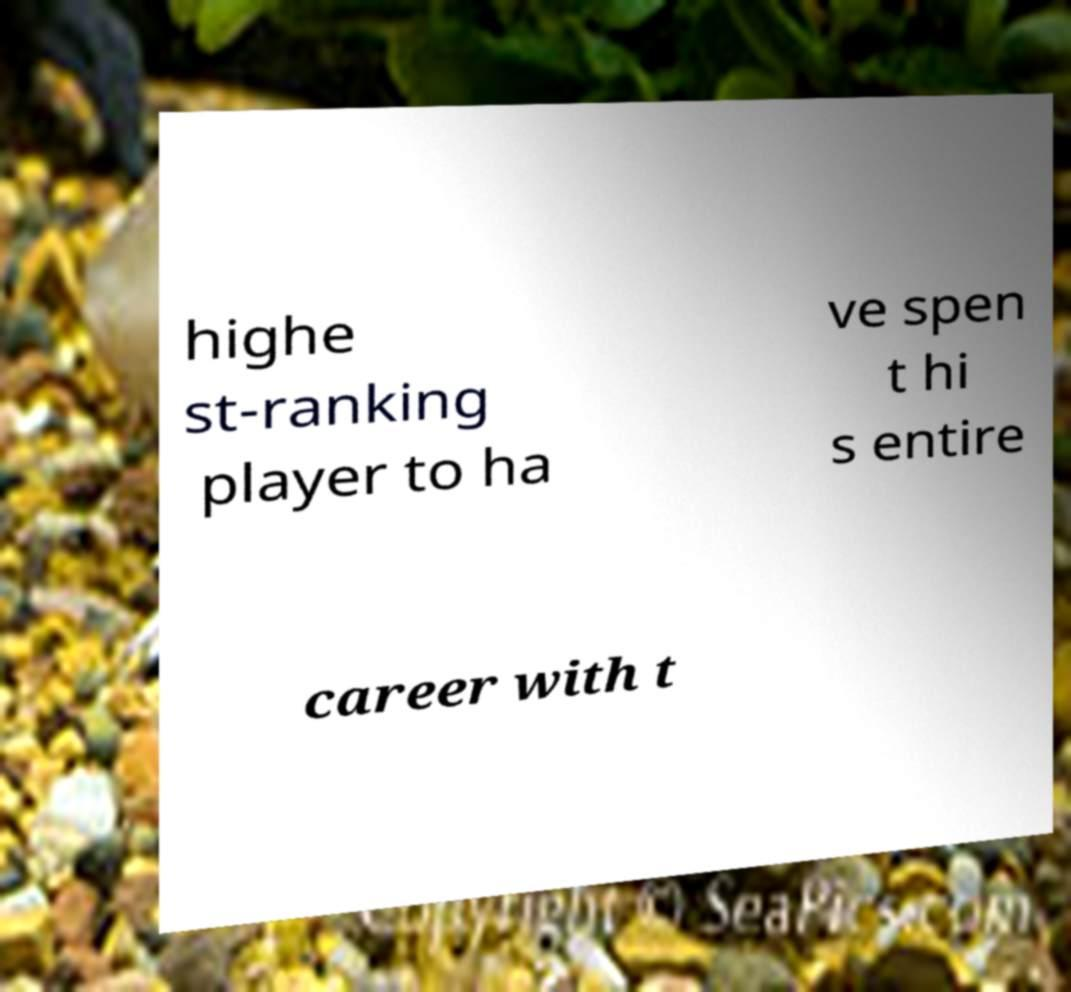There's text embedded in this image that I need extracted. Can you transcribe it verbatim? highe st-ranking player to ha ve spen t hi s entire career with t 